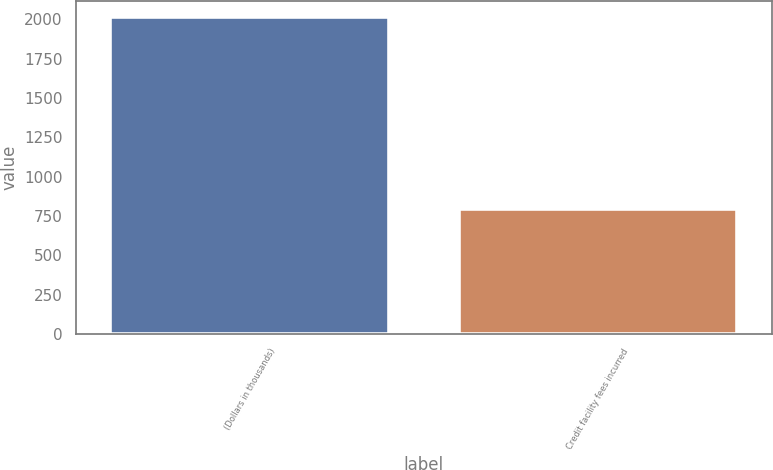<chart> <loc_0><loc_0><loc_500><loc_500><bar_chart><fcel>(Dollars in thousands)<fcel>Credit facility fees incurred<nl><fcel>2016<fcel>793<nl></chart> 